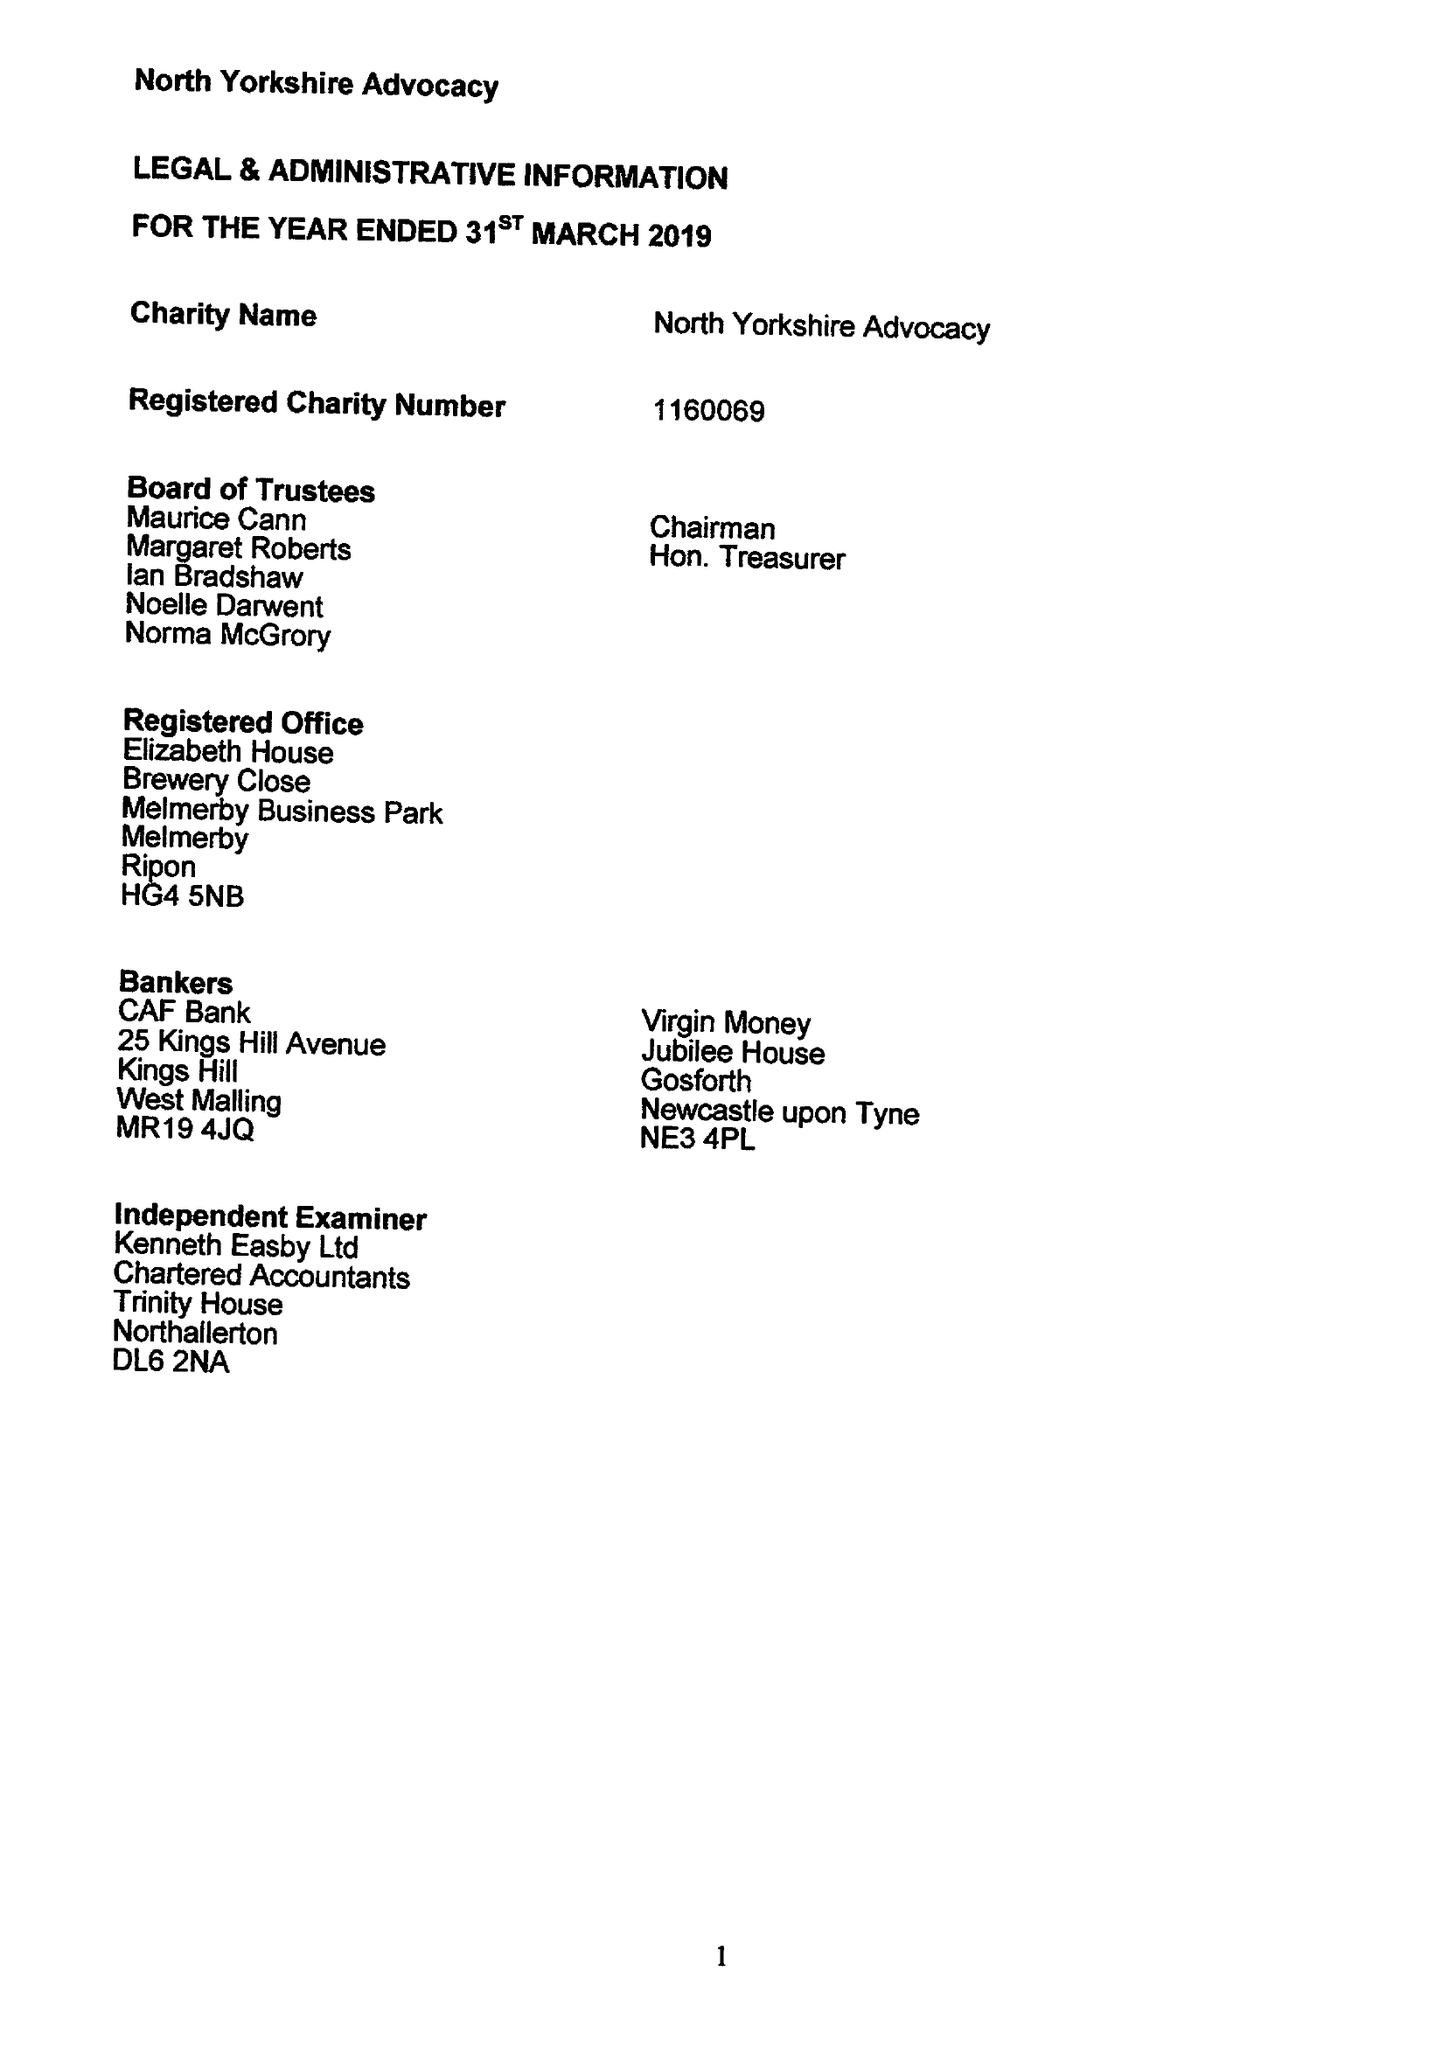What is the value for the spending_annually_in_british_pounds?
Answer the question using a single word or phrase. 145524.00 